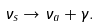Convert formula to latex. <formula><loc_0><loc_0><loc_500><loc_500>\nu _ { s } \rightarrow \nu _ { a } + \gamma .</formula> 